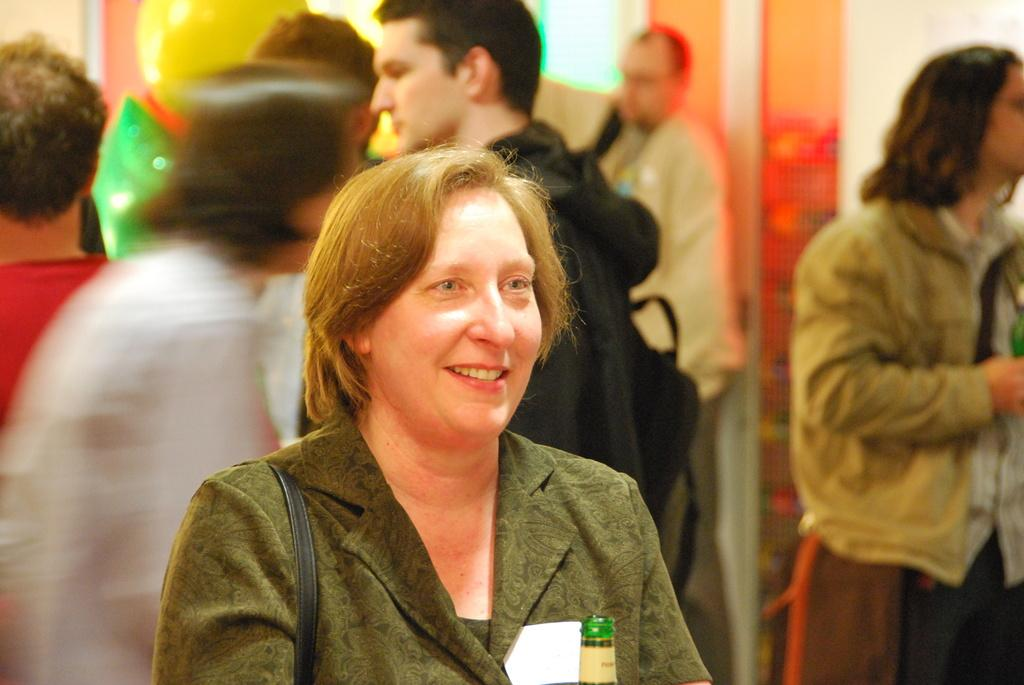Who is the main subject in the image? There is a woman in the center of the image. What is the woman wearing? The woman is wearing a green jacket. What is the woman holding in the image? The woman is holding a bag. Can you describe the background of the image? There is a group of people in the background of the image. What type of cake is being shared among the group of people in the image? There is no cake present in the image; the woman is holding a bag. How does the woman's crush react to her in the image? There is no information about a crush in the image, as it only shows the woman and a group of people in the background. 